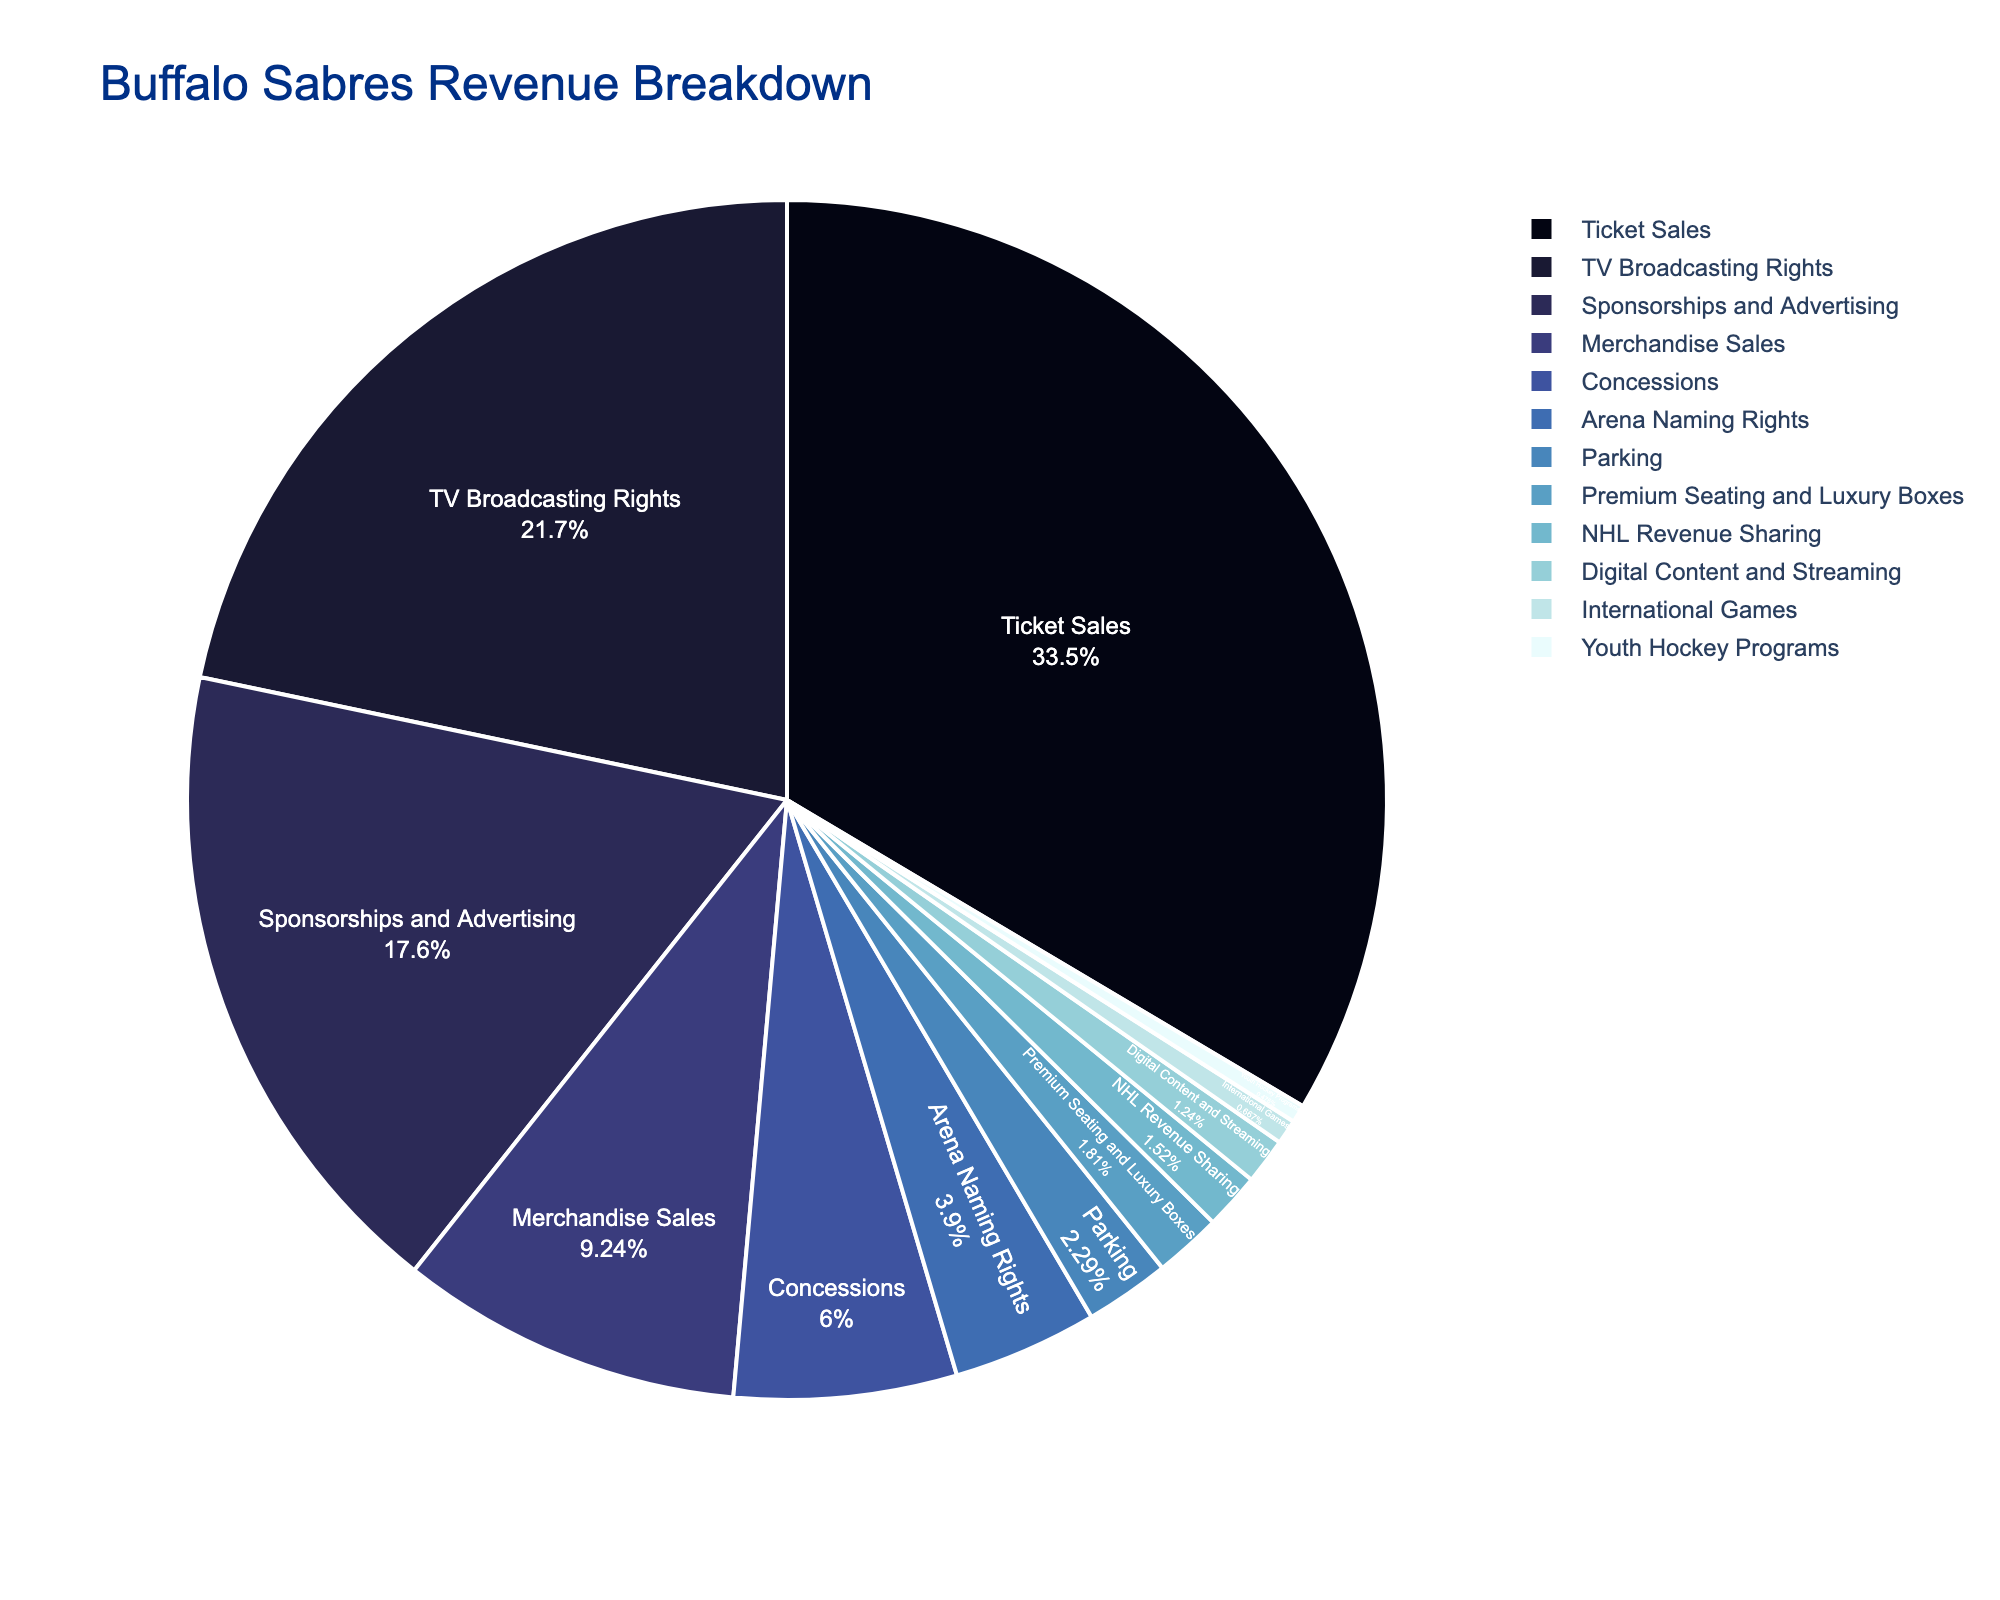What percentage of revenue comes from ticket sales? The pie chart shows different revenue sources with their corresponding percentages. Ticket sales are listed at 35.2%.
Answer: 35.2% Which revenue source contributes more, merchandise sales or concessions? By looking at the pie chart, we see that merchandise sales are responsible for 9.7%, while concessions account for 6.3%.
Answer: Merchandise sales What is the combined percentage of revenue from TV broadcasting rights and sponsorships and advertising? TV broadcasting rights contribute 22.8%, and sponsorships and advertising contribute 18.5%. Adding these together gives 22.8 + 18.5 = 41.3%.
Answer: 41.3% Is digital content and streaming a significant revenue source compared to premium seating and luxury boxes? The pie chart shows digital content and streaming at 1.3% and premium seating and luxury boxes at 1.9%. Since 1.3% is less than 1.9%, digital content and streaming contribute less revenue.
Answer: No Are there any revenue sources that contribute less than 1%? From the pie chart, we observe that NHL revenue sharing (1.6%), digital content and streaming (1.3%), international games (0.7%), and youth hockey programs (0.5%) contribute less than 1% each.
Answer: Yes What is the difference in revenue contribution between ticket sales and TV broadcasting rights? Ticket sales contribute 35.2%, while TV broadcasting rights contribute 22.8%. The difference is 35.2 - 22.8 = 12.4%.
Answer: 12.4% Which revenue source contributes the least to the Buffalo Sabres' revenue? According to the pie chart, youth hockey programs contribute the least with 0.5%.
Answer: Youth hockey programs By combining the percentages of concessions and parking, do they contribute more than merchandise sales? Concessions account for 6.3% and parking accounts for 2.4%. Combined, this amounts to 6.3 + 2.4 = 8.7%, which is less than merchandise sales at 9.7%.
Answer: No What is the sum of the revenue percentages from the smallest four revenue sources? The smallest four sources are youth hockey programs (0.5%), international games (0.7%), digital content and streaming (1.3%), and NHL revenue sharing (1.6%). Summing these gives 0.5 + 0.7 + 1.3 + 1.6 = 4.1%.
Answer: 4.1% Which revenue sources together constitute more than half of the total revenue? Adding the largest sources: ticket sales (35.2%), TV broadcasting rights (22.8%), and sponsorships and advertising (18.5%) together gives 35.2 + 22.8 = 58, then 58 + 18.5 = 76.5%, which is more than half.
Answer: Ticket Sales, TV Broadcasting Rights, Sponsorships and Advertising 